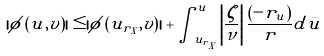Convert formula to latex. <formula><loc_0><loc_0><loc_500><loc_500>| \phi \left ( u , v \right ) | \leq | \phi \left ( u _ { r _ { X } } , v \right ) | + \int _ { u _ { r _ { X } } } ^ { u } \left | \frac { \zeta } { \nu } \right | \frac { \left ( - r _ { u } \right ) } { r } d \bar { u }</formula> 